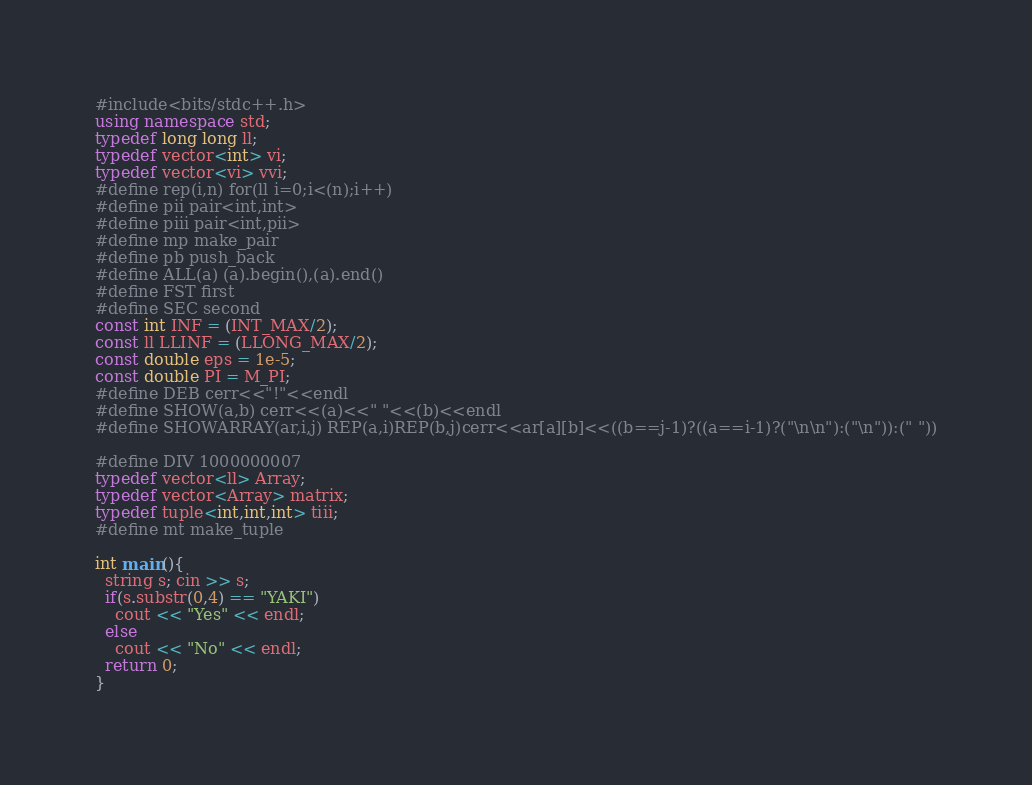<code> <loc_0><loc_0><loc_500><loc_500><_C++_>#include<bits/stdc++.h>
using namespace std;  
typedef long long ll;
typedef vector<int> vi;
typedef vector<vi> vvi;
#define rep(i,n) for(ll i=0;i<(n);i++)  
#define pii pair<int,int>
#define piii pair<int,pii>
#define mp make_pair
#define pb push_back  
#define ALL(a) (a).begin(),(a).end()
#define FST first
#define SEC second  
const int INF = (INT_MAX/2);
const ll LLINF = (LLONG_MAX/2);
const double eps = 1e-5;
const double PI = M_PI;  
#define DEB cerr<<"!"<<endl
#define SHOW(a,b) cerr<<(a)<<" "<<(b)<<endl
#define SHOWARRAY(ar,i,j) REP(a,i)REP(b,j)cerr<<ar[a][b]<<((b==j-1)?((a==i-1)?("\n\n"):("\n")):(" "))
  
#define DIV 1000000007
typedef vector<ll> Array;
typedef vector<Array> matrix;
typedef tuple<int,int,int> tiii;
#define mt make_tuple
 
int main(){
  string s; cin >> s;
  if(s.substr(0,4) == "YAKI")
    cout << "Yes" << endl;
  else
    cout << "No" << endl;
  return 0;
}</code> 